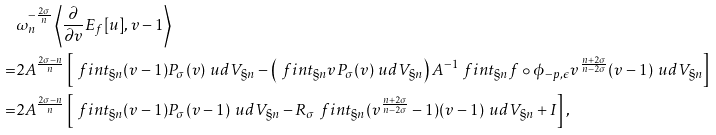<formula> <loc_0><loc_0><loc_500><loc_500>& \omega _ { n } ^ { - \frac { 2 \sigma } { n } } \left \langle \frac { \partial } { \partial v } E _ { f } [ u ] , v - 1 \right \rangle \\ = & 2 A ^ { \frac { 2 \sigma - n } { n } } \left [ \ f i n t _ { \S n } ( v - 1 ) P _ { \sigma } ( v ) \ u d V _ { \S n } - \left ( \ f i n t _ { \S n } v P _ { \sigma } ( v ) \ u d V _ { \S n } \right ) A ^ { - 1 } \ f i n t _ { \S n } f \circ \phi _ { - p , \epsilon } v ^ { \frac { n + 2 \sigma } { n - 2 \sigma } } ( v - 1 ) \ u d V _ { \S n } \right ] \\ = & 2 A ^ { \frac { 2 \sigma - n } { n } } \left [ \ f i n t _ { \S n } ( v - 1 ) P _ { \sigma } ( v - 1 ) \ u d V _ { \S n } - R _ { \sigma } \ f i n t _ { \S n } ( v ^ { \frac { n + 2 \sigma } { n - 2 \sigma } } - 1 ) ( v - 1 ) \ u d V _ { \S n } + I \right ] ,</formula> 